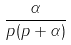<formula> <loc_0><loc_0><loc_500><loc_500>\frac { \alpha } { p ( p + \alpha ) }</formula> 